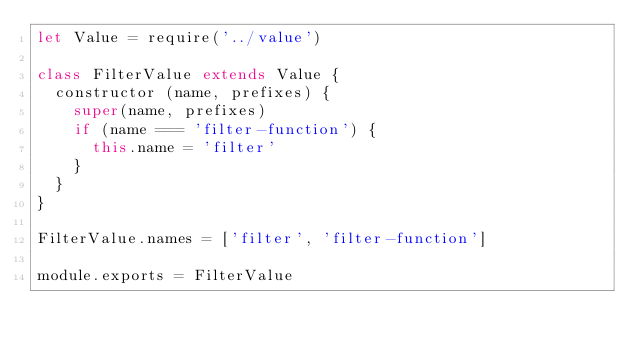Convert code to text. <code><loc_0><loc_0><loc_500><loc_500><_JavaScript_>let Value = require('../value')

class FilterValue extends Value {
  constructor (name, prefixes) {
    super(name, prefixes)
    if (name === 'filter-function') {
      this.name = 'filter'
    }
  }
}

FilterValue.names = ['filter', 'filter-function']

module.exports = FilterValue
</code> 